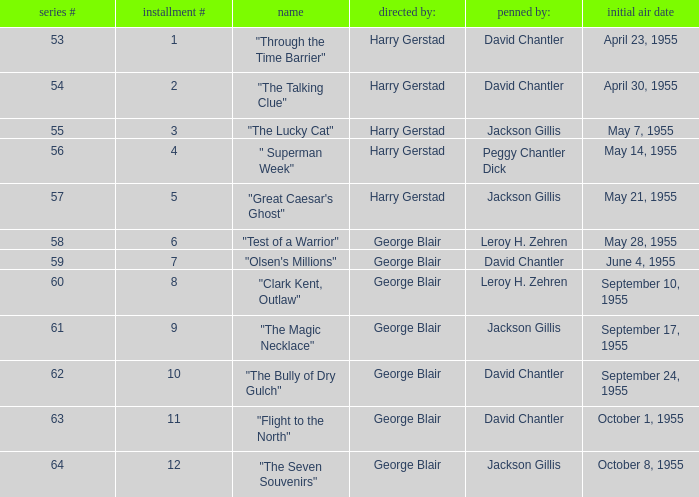Which Season originally aired on September 17, 1955 9.0. 